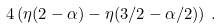<formula> <loc_0><loc_0><loc_500><loc_500>4 \left ( \eta ( 2 - \alpha ) - \eta ( 3 / 2 - \alpha / 2 ) \right ) \, .</formula> 